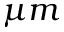<formula> <loc_0><loc_0><loc_500><loc_500>\mu m</formula> 